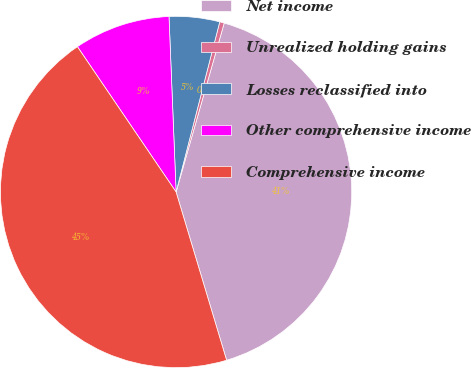Convert chart to OTSL. <chart><loc_0><loc_0><loc_500><loc_500><pie_chart><fcel>Net income<fcel>Unrealized holding gains<fcel>Losses reclassified into<fcel>Other comprehensive income<fcel>Comprehensive income<nl><fcel>40.94%<fcel>0.42%<fcel>4.64%<fcel>8.85%<fcel>45.15%<nl></chart> 